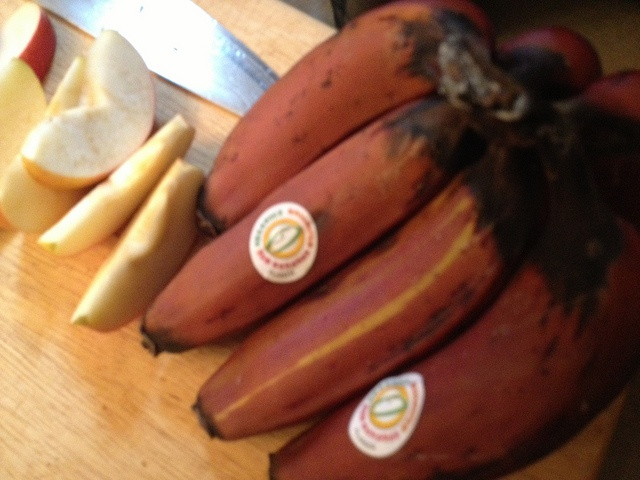Describe the objects in this image and their specific colors. I can see banana in tan, black, maroon, and brown tones, apple in tan, beige, and brown tones, and knife in tan, white, darkgray, and lightblue tones in this image. 